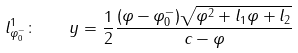<formula> <loc_0><loc_0><loc_500><loc_500>l _ { \varphi _ { 0 } ^ { - } } ^ { 1 } \colon \quad y = \frac { 1 } { 2 } \frac { ( \varphi - \varphi _ { 0 } ^ { - } ) \sqrt { \varphi ^ { 2 } + l _ { 1 } \varphi + l _ { 2 } } } { c - \varphi }</formula> 